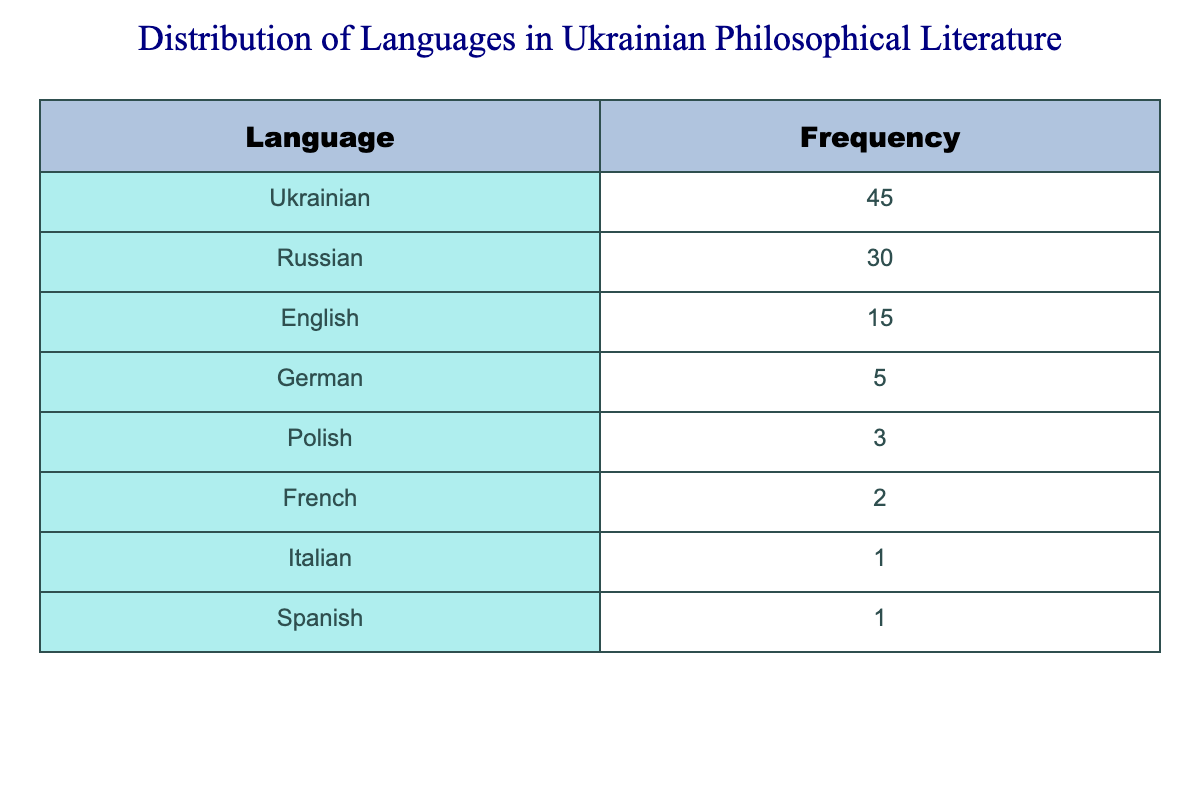What is the most frequently used language in Ukrainian philosophical literature? The table indicates that the language with the highest frequency is Ukrainian, with a total of 45 publications.
Answer: Ukrainian What is the frequency of publications in English? According to the table, there are 15 publications in English.
Answer: 15 Which language has the lowest frequency in the table? Looking at the table, both Italian and Spanish have the lowest frequency, both with 1 publication.
Answer: Italian and Spanish How many more publications are there in Ukrainian than in Russian? Ukrainian publications total 45, while Russian publications total 30. The difference is 45 - 30 = 15.
Answer: 15 Is the frequency of publications in Polish higher than that in French? The frequency for Polish is 3 and for French is 2. Since 3 is greater than 2, the statement is true.
Answer: Yes What is the total frequency of publications for all languages listed? To find the total, we sum all frequencies: 45 + 30 + 15 + 5 + 3 + 2 + 1 + 1 = 102.
Answer: 102 Which language group exceeds 50 in total frequency? From the table, only Ukrainian exceeds 50 with a frequency of 45 for Ukrainian, so no single language exceeds 50 when counting ones less than that.
Answer: No What percentage of publications are in Russian compared to the total number of publications? The total number of publications is 102, and Russian has 30. The percentage is (30/102) * 100 = approximately 29.41%.
Answer: 29.41% If you combine the frequencies of French, Italian, and Spanish, what is the total? The frequencies are 2 for French, 1 for Italian, and 1 for Spanish. Adding them results in 2 + 1 + 1 = 4.
Answer: 4 